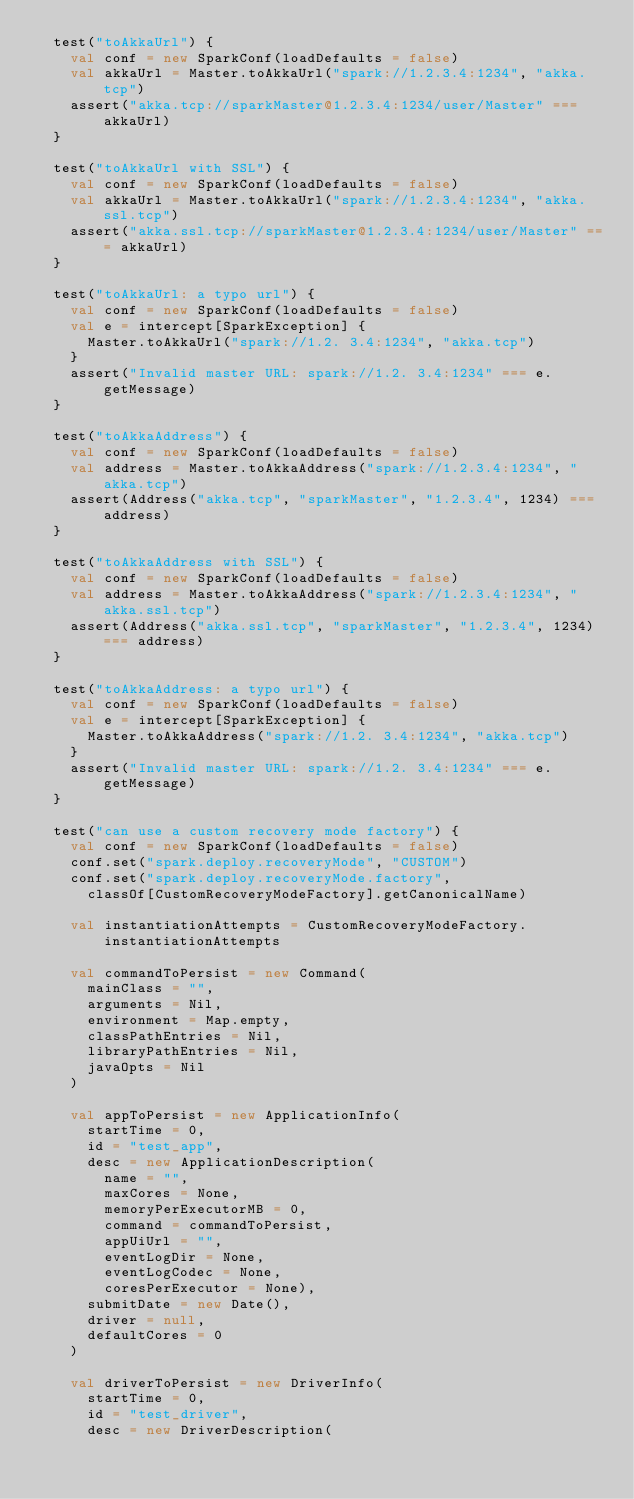Convert code to text. <code><loc_0><loc_0><loc_500><loc_500><_Scala_>  test("toAkkaUrl") {
    val conf = new SparkConf(loadDefaults = false)
    val akkaUrl = Master.toAkkaUrl("spark://1.2.3.4:1234", "akka.tcp")
    assert("akka.tcp://sparkMaster@1.2.3.4:1234/user/Master" === akkaUrl)
  }

  test("toAkkaUrl with SSL") {
    val conf = new SparkConf(loadDefaults = false)
    val akkaUrl = Master.toAkkaUrl("spark://1.2.3.4:1234", "akka.ssl.tcp")
    assert("akka.ssl.tcp://sparkMaster@1.2.3.4:1234/user/Master" === akkaUrl)
  }

  test("toAkkaUrl: a typo url") {
    val conf = new SparkConf(loadDefaults = false)
    val e = intercept[SparkException] {
      Master.toAkkaUrl("spark://1.2. 3.4:1234", "akka.tcp")
    }
    assert("Invalid master URL: spark://1.2. 3.4:1234" === e.getMessage)
  }

  test("toAkkaAddress") {
    val conf = new SparkConf(loadDefaults = false)
    val address = Master.toAkkaAddress("spark://1.2.3.4:1234", "akka.tcp")
    assert(Address("akka.tcp", "sparkMaster", "1.2.3.4", 1234) === address)
  }

  test("toAkkaAddress with SSL") {
    val conf = new SparkConf(loadDefaults = false)
    val address = Master.toAkkaAddress("spark://1.2.3.4:1234", "akka.ssl.tcp")
    assert(Address("akka.ssl.tcp", "sparkMaster", "1.2.3.4", 1234) === address)
  }

  test("toAkkaAddress: a typo url") {
    val conf = new SparkConf(loadDefaults = false)
    val e = intercept[SparkException] {
      Master.toAkkaAddress("spark://1.2. 3.4:1234", "akka.tcp")
    }
    assert("Invalid master URL: spark://1.2. 3.4:1234" === e.getMessage)
  }

  test("can use a custom recovery mode factory") {
    val conf = new SparkConf(loadDefaults = false)
    conf.set("spark.deploy.recoveryMode", "CUSTOM")
    conf.set("spark.deploy.recoveryMode.factory",
      classOf[CustomRecoveryModeFactory].getCanonicalName)

    val instantiationAttempts = CustomRecoveryModeFactory.instantiationAttempts

    val commandToPersist = new Command(
      mainClass = "",
      arguments = Nil,
      environment = Map.empty,
      classPathEntries = Nil,
      libraryPathEntries = Nil,
      javaOpts = Nil
    )

    val appToPersist = new ApplicationInfo(
      startTime = 0,
      id = "test_app",
      desc = new ApplicationDescription(
        name = "",
        maxCores = None,
        memoryPerExecutorMB = 0,
        command = commandToPersist,
        appUiUrl = "",
        eventLogDir = None,
        eventLogCodec = None,
        coresPerExecutor = None),
      submitDate = new Date(),
      driver = null,
      defaultCores = 0
    )

    val driverToPersist = new DriverInfo(
      startTime = 0,
      id = "test_driver",
      desc = new DriverDescription(</code> 